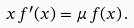<formula> <loc_0><loc_0><loc_500><loc_500>x \, f ^ { \prime } ( x ) = \mu \, f ( x ) \, .</formula> 